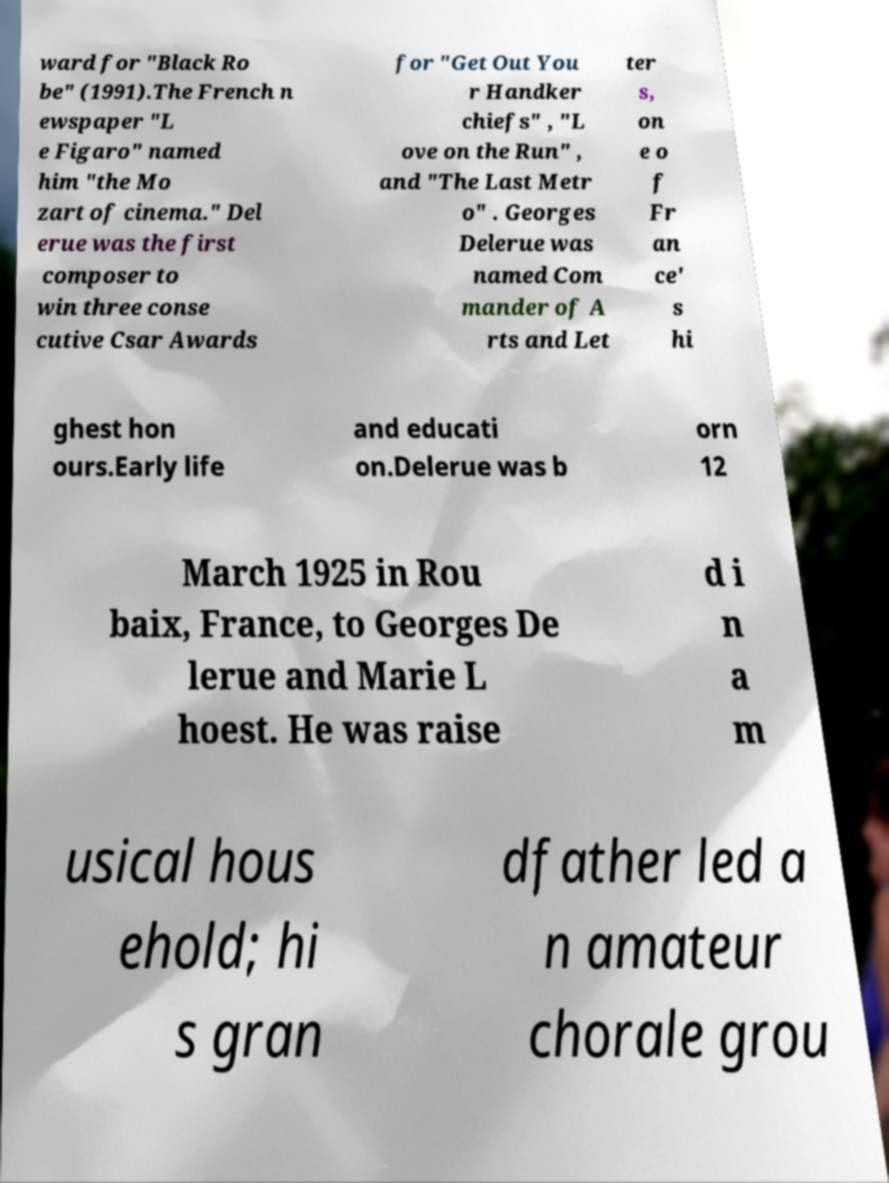Could you extract and type out the text from this image? ward for "Black Ro be" (1991).The French n ewspaper "L e Figaro" named him "the Mo zart of cinema." Del erue was the first composer to win three conse cutive Csar Awards for "Get Out You r Handker chiefs" , "L ove on the Run" , and "The Last Metr o" . Georges Delerue was named Com mander of A rts and Let ter s, on e o f Fr an ce' s hi ghest hon ours.Early life and educati on.Delerue was b orn 12 March 1925 in Rou baix, France, to Georges De lerue and Marie L hoest. He was raise d i n a m usical hous ehold; hi s gran dfather led a n amateur chorale grou 